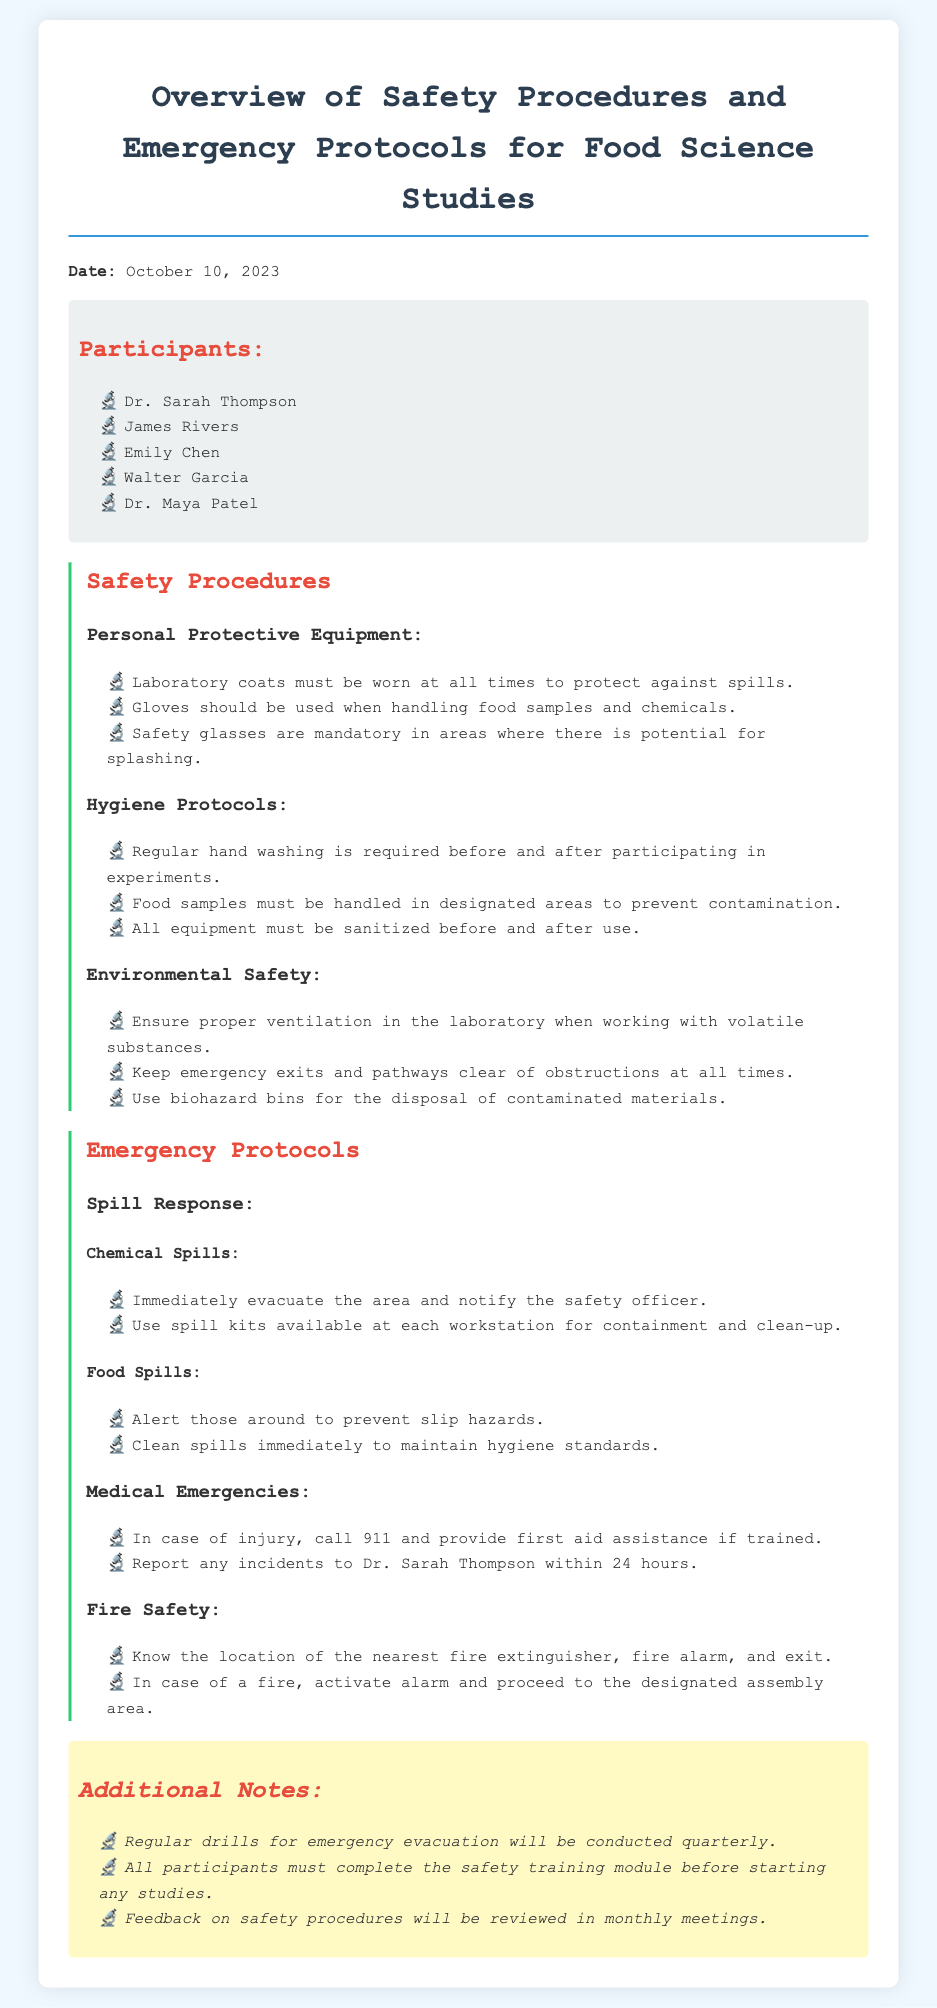What is the date of the meeting? The date of the meeting is stated at the beginning of the document.
Answer: October 10, 2023 Who is the first participant listed? The participants' names are enumerated in a section of the document, and the first name mentioned is considered.
Answer: Dr. Sarah Thompson What type of equipment must be worn at all times? The safety procedures outline the requirements for personal protective equipment, specifically what must be worn.
Answer: Laboratory coats What action should be taken in case of a chemical spill? The emergency protocols detail the steps to take under specific situations, including a chemical spill.
Answer: Notify the safety officer How frequently will emergency evacuation drills be conducted? Additional notes section mentions the frequency of certain safety practices, including drills.
Answer: Quarterly What should be done before starting any studies? The additional notes emphasize a requirement that must be fulfilled prior to starting experiments.
Answer: Complete the safety training module What should you do if there is a fire? Fire safety procedures outline the necessary actions when faced with a fire situation.
Answer: Activate alarm How long do incidents need to be reported after an injury? The emergency protocols specify a time frame for reporting incidents involving injuries.
Answer: 24 hours 